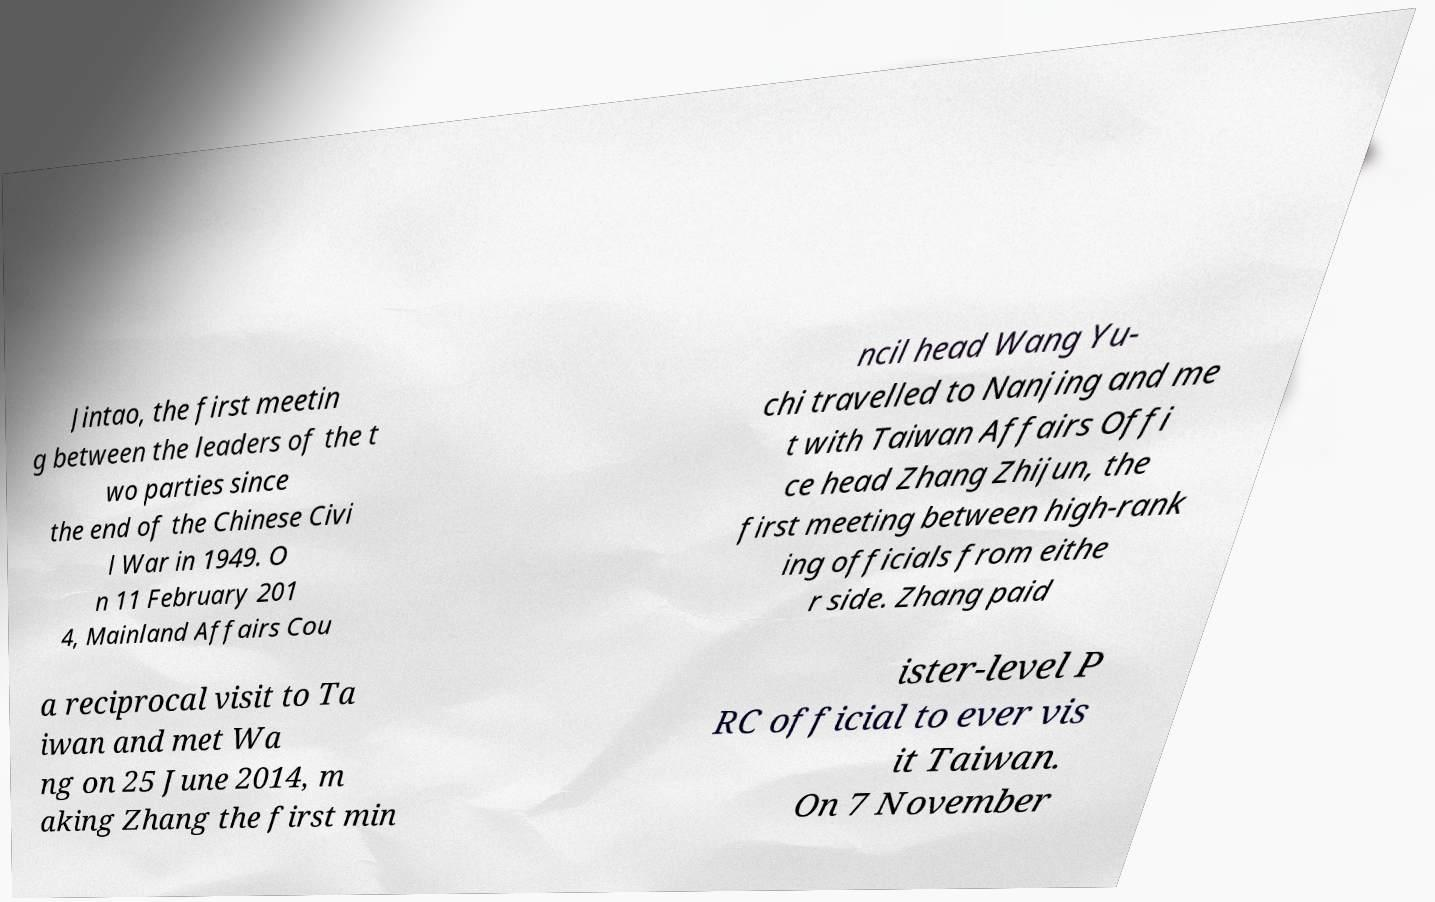What messages or text are displayed in this image? I need them in a readable, typed format. Jintao, the first meetin g between the leaders of the t wo parties since the end of the Chinese Civi l War in 1949. O n 11 February 201 4, Mainland Affairs Cou ncil head Wang Yu- chi travelled to Nanjing and me t with Taiwan Affairs Offi ce head Zhang Zhijun, the first meeting between high-rank ing officials from eithe r side. Zhang paid a reciprocal visit to Ta iwan and met Wa ng on 25 June 2014, m aking Zhang the first min ister-level P RC official to ever vis it Taiwan. On 7 November 